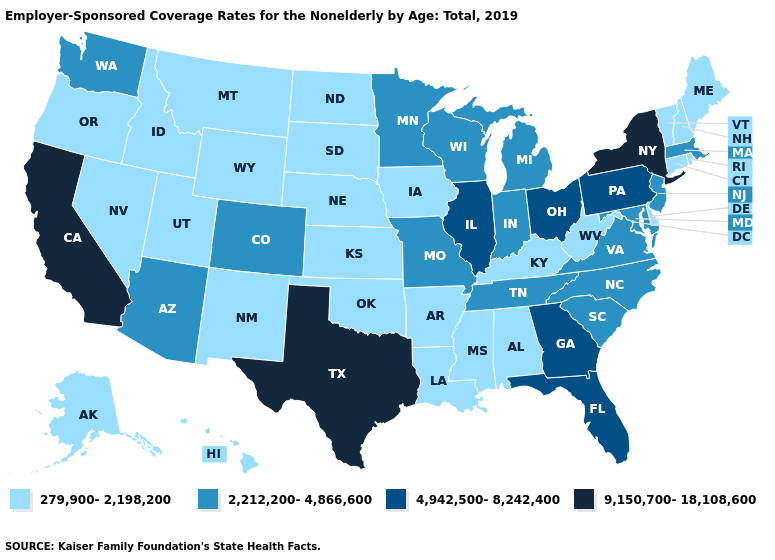Name the states that have a value in the range 9,150,700-18,108,600?
Answer briefly. California, New York, Texas. Does New Jersey have the lowest value in the Northeast?
Give a very brief answer. No. Name the states that have a value in the range 9,150,700-18,108,600?
Be succinct. California, New York, Texas. What is the value of Massachusetts?
Concise answer only. 2,212,200-4,866,600. Which states have the lowest value in the South?
Concise answer only. Alabama, Arkansas, Delaware, Kentucky, Louisiana, Mississippi, Oklahoma, West Virginia. Name the states that have a value in the range 2,212,200-4,866,600?
Give a very brief answer. Arizona, Colorado, Indiana, Maryland, Massachusetts, Michigan, Minnesota, Missouri, New Jersey, North Carolina, South Carolina, Tennessee, Virginia, Washington, Wisconsin. Does New York have the highest value in the Northeast?
Short answer required. Yes. Name the states that have a value in the range 9,150,700-18,108,600?
Keep it brief. California, New York, Texas. Does Mississippi have the lowest value in the USA?
Keep it brief. Yes. What is the highest value in states that border Tennessee?
Be succinct. 4,942,500-8,242,400. Does Hawaii have the same value as Nevada?
Write a very short answer. Yes. Does the map have missing data?
Short answer required. No. What is the lowest value in states that border West Virginia?
Quick response, please. 279,900-2,198,200. What is the value of South Dakota?
Give a very brief answer. 279,900-2,198,200. What is the highest value in states that border South Carolina?
Quick response, please. 4,942,500-8,242,400. 